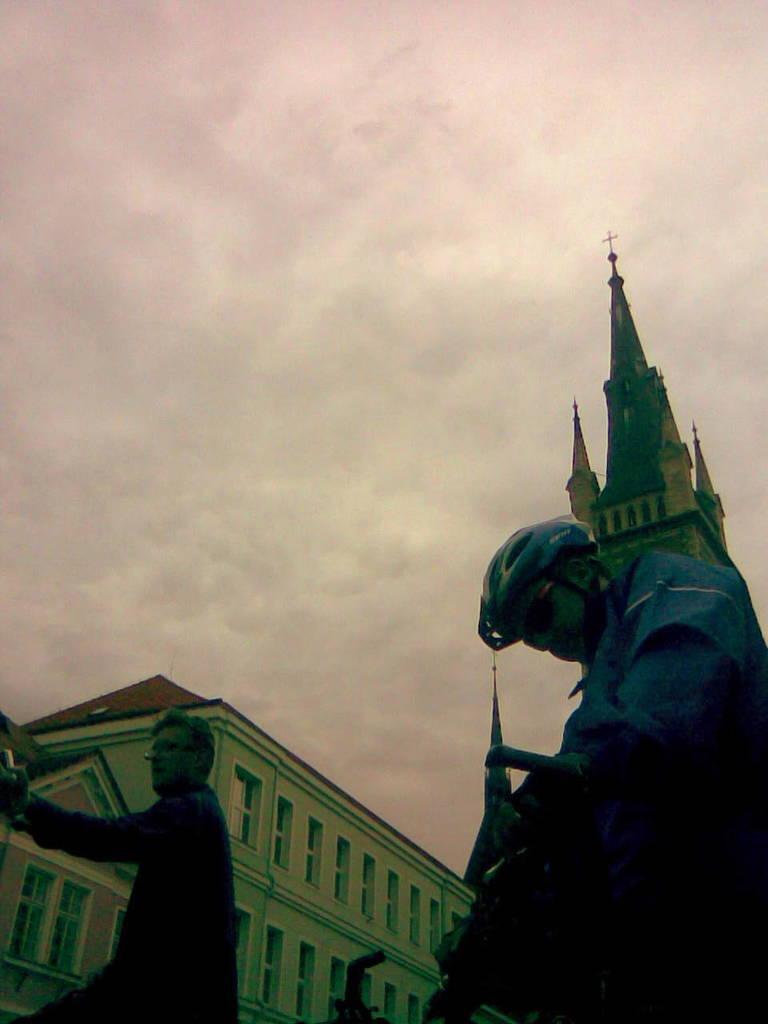Could you give a brief overview of what you see in this image? This image consists of sky at the top. There is building at the bottom. There are two persons at the bottom. One is wearing a helmet. 